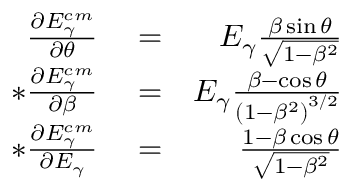<formula> <loc_0><loc_0><loc_500><loc_500>\begin{array} { r l r } { \frac { \partial E _ { \gamma } ^ { c m } } { \partial \theta } } & = } & E _ { \gamma } \frac { \beta \sin { \theta } } { \sqrt { 1 - \beta ^ { 2 } } } \\ { * \frac { \partial E _ { \gamma } ^ { c m } } { \partial \beta } } & = } & E _ { \gamma } \frac { \beta - \cos { \theta } } { \left ( 1 - \beta ^ { 2 } \right ) ^ { 3 / 2 } } \\ { * \frac { \partial E _ { \gamma } ^ { c m } } { \partial E _ { \gamma } } } & = } & \frac { 1 - \beta \cos { \theta } } { \sqrt { 1 - \beta ^ { 2 } } } } \end{array}</formula> 